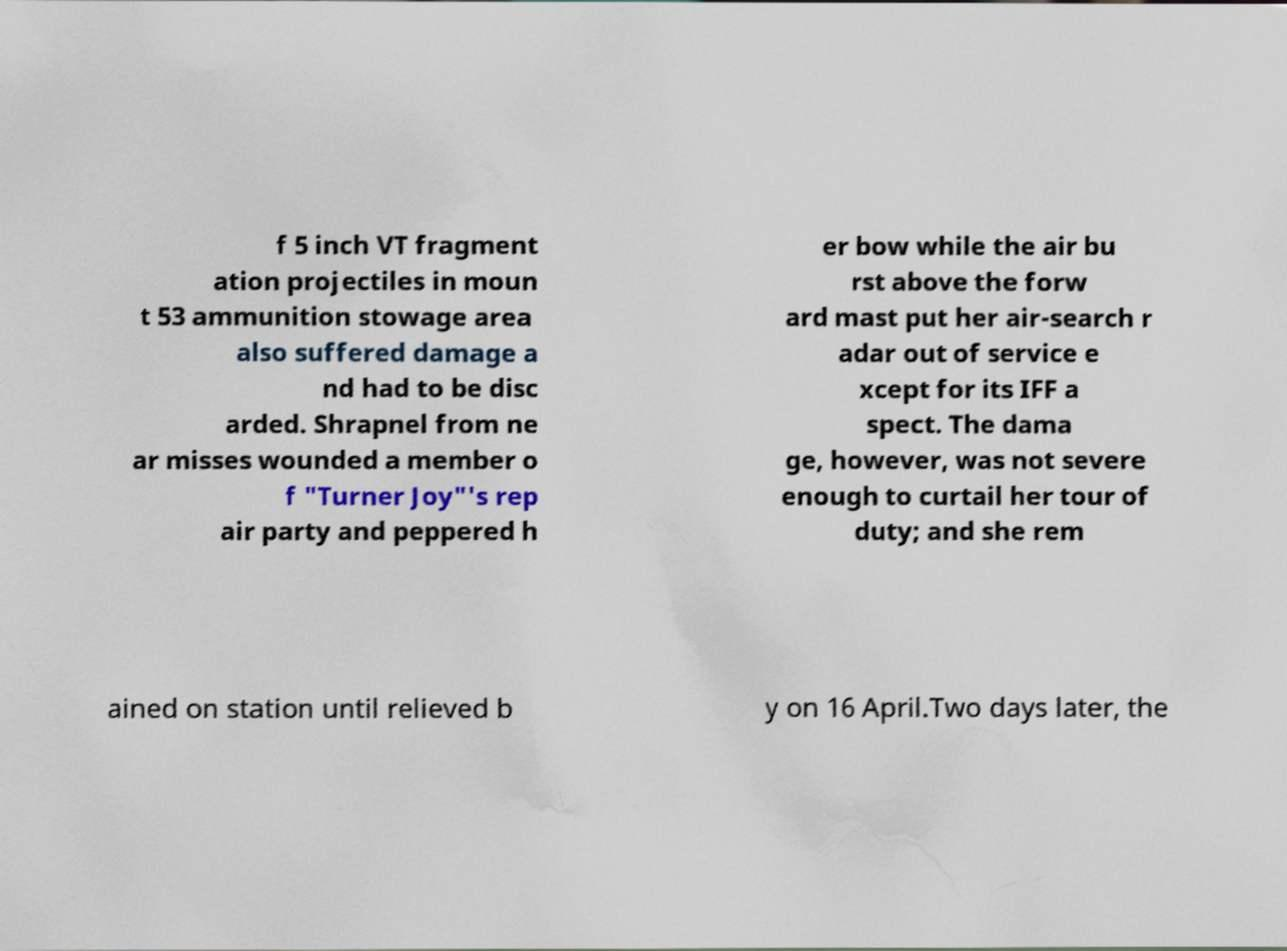There's text embedded in this image that I need extracted. Can you transcribe it verbatim? f 5 inch VT fragment ation projectiles in moun t 53 ammunition stowage area also suffered damage a nd had to be disc arded. Shrapnel from ne ar misses wounded a member o f "Turner Joy"'s rep air party and peppered h er bow while the air bu rst above the forw ard mast put her air-search r adar out of service e xcept for its IFF a spect. The dama ge, however, was not severe enough to curtail her tour of duty; and she rem ained on station until relieved b y on 16 April.Two days later, the 